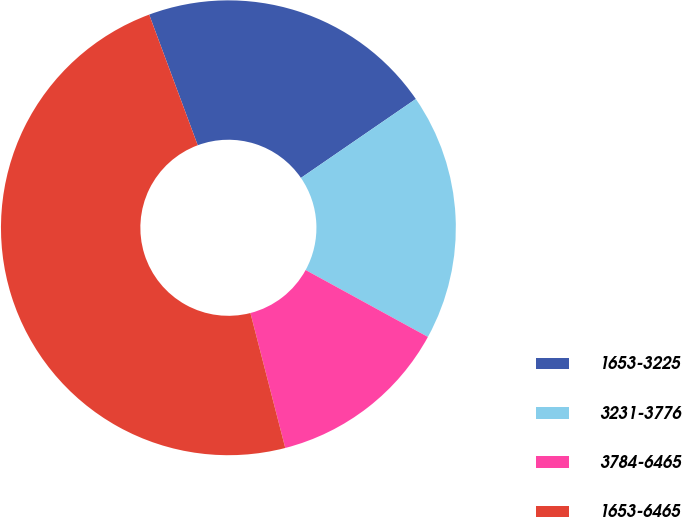<chart> <loc_0><loc_0><loc_500><loc_500><pie_chart><fcel>1653-3225<fcel>3231-3776<fcel>3784-6465<fcel>1653-6465<nl><fcel>21.08%<fcel>17.55%<fcel>13.01%<fcel>48.36%<nl></chart> 